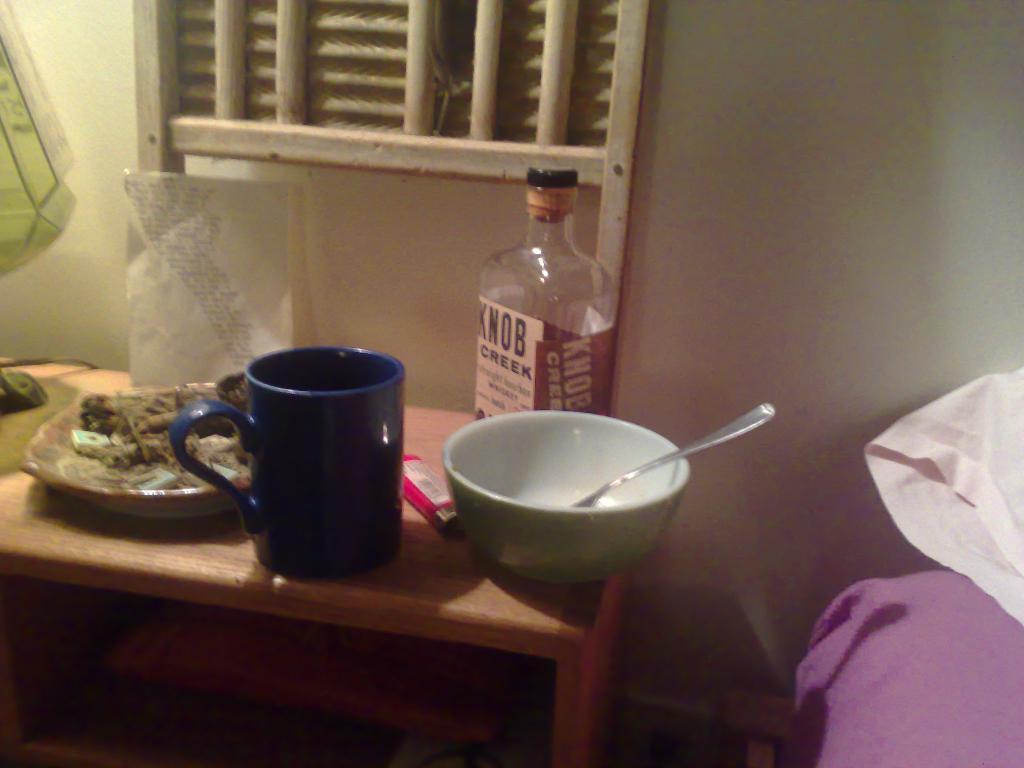What whiskey is on the nighstand?
Offer a very short reply. Knob creek. 